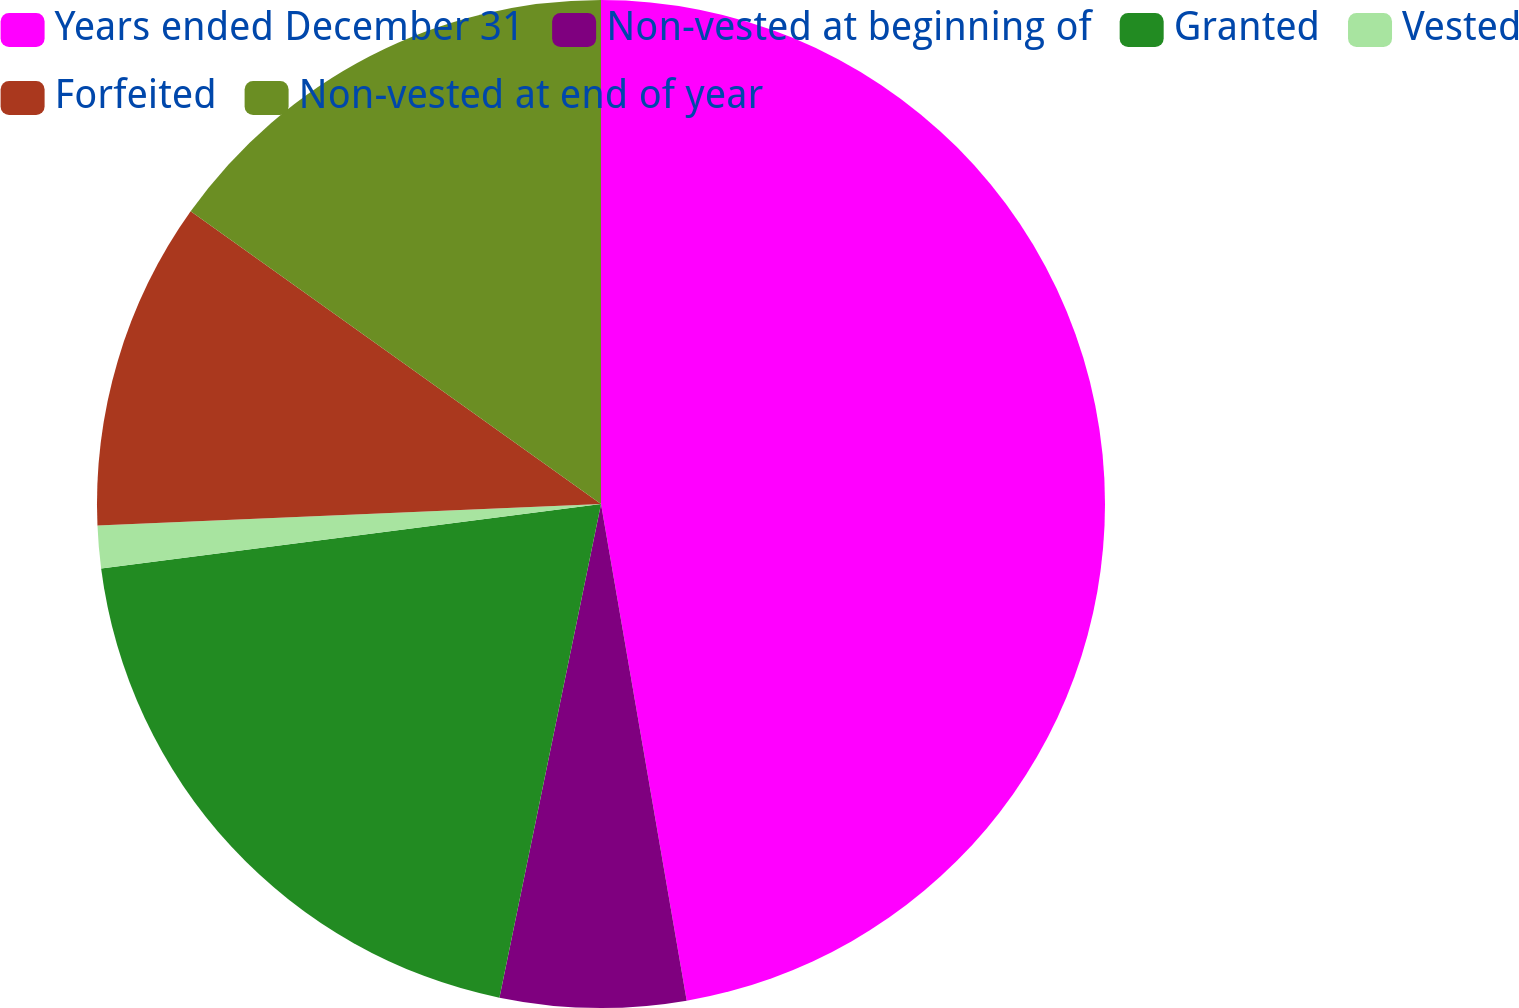Convert chart to OTSL. <chart><loc_0><loc_0><loc_500><loc_500><pie_chart><fcel>Years ended December 31<fcel>Non-vested at beginning of<fcel>Granted<fcel>Vested<fcel>Forfeited<fcel>Non-vested at end of year<nl><fcel>47.28%<fcel>5.95%<fcel>19.73%<fcel>1.36%<fcel>10.54%<fcel>15.14%<nl></chart> 